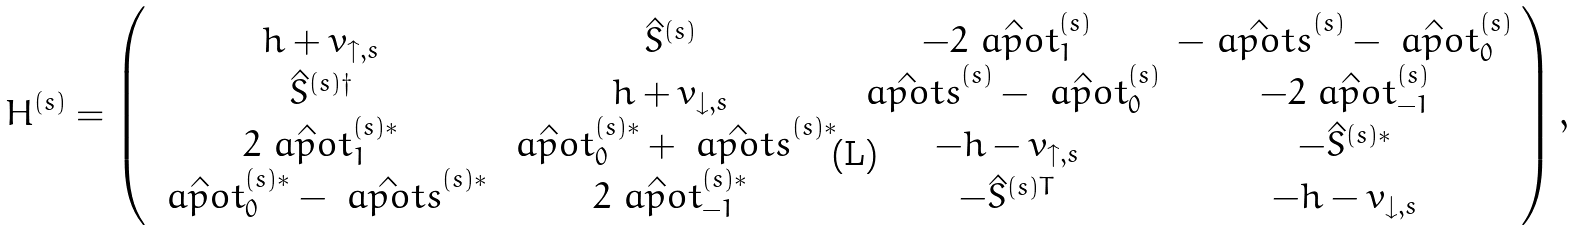Convert formula to latex. <formula><loc_0><loc_0><loc_500><loc_500>H ^ { ( s ) } = \left ( \begin{array} { c c c c } h + v _ { \uparrow , s } & \hat { S } ^ { ( s ) } & - 2 \hat { \ a p o t } _ { 1 } ^ { ( s ) } & { - \hat { \ a p o t s } ^ { ( s ) } - \hat { \ a p o t } _ { 0 } ^ { ( s ) } } \\ \hat { S } ^ { ( s ) \dagger } & h + v _ { \downarrow , s } & { \hat { \ a p o t s } ^ { ( s ) } - \hat { \ a p o t } _ { 0 } ^ { ( s ) } } & - 2 \hat { \ a p o t } ^ { ( s ) } _ { - 1 } \\ 2 \hat { \ a p o t } _ { 1 } ^ { ( s ) * } & { \hat { \ a p o t } _ { 0 } ^ { ( s ) * } + \hat { \ a p o t s } ^ { ( s ) * } } & - h - v _ { \uparrow , s } & - \hat { S } ^ { ( s ) * } \\ { \hat { \ a p o t } _ { 0 } ^ { ( s ) * } - \hat { \ a p o t s } ^ { ( s ) * } } & 2 \hat { \ a p o t } _ { - 1 } ^ { ( s ) * } & - \hat { S } ^ { ( s ) T } & - h - v _ { \downarrow , s } \end{array} \right ) ,</formula> 